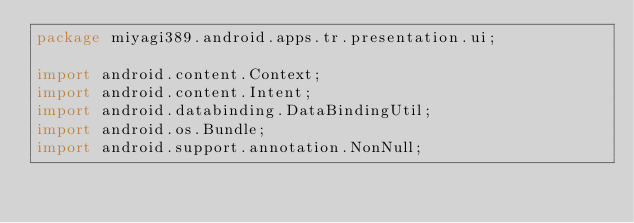<code> <loc_0><loc_0><loc_500><loc_500><_Java_>package miyagi389.android.apps.tr.presentation.ui;

import android.content.Context;
import android.content.Intent;
import android.databinding.DataBindingUtil;
import android.os.Bundle;
import android.support.annotation.NonNull;</code> 